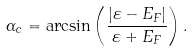Convert formula to latex. <formula><loc_0><loc_0><loc_500><loc_500>\alpha _ { c } = \arcsin \left ( \frac { | \varepsilon - E _ { F } | } { \varepsilon + E _ { F } } \right ) .</formula> 